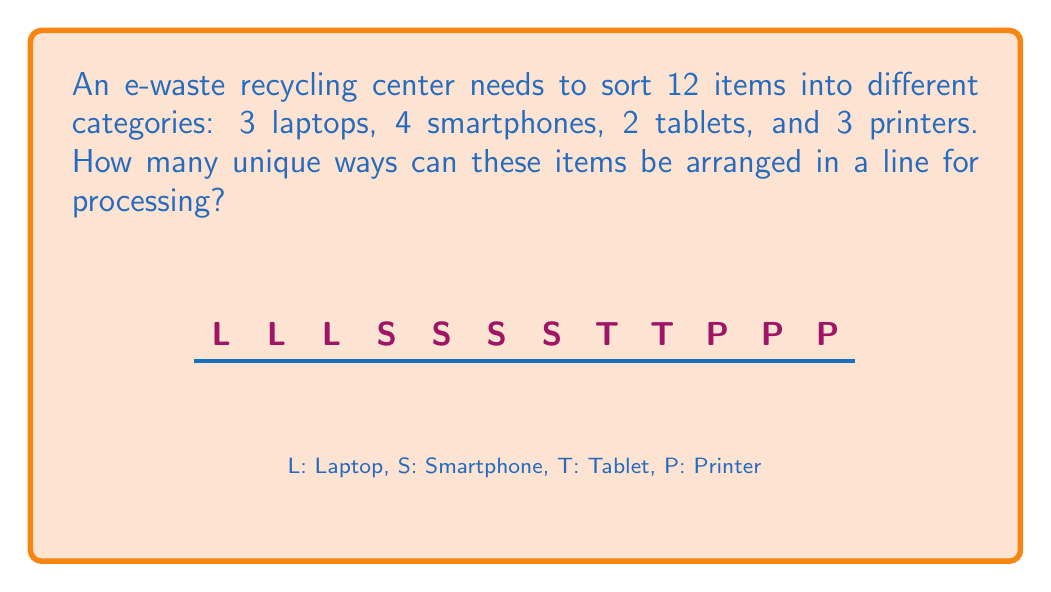What is the answer to this math problem? To solve this problem, we need to use the concept of permutations with repetition. The formula for this is:

$$\frac{n!}{n_1! \cdot n_2! \cdot ... \cdot n_k!}$$

Where:
- $n$ is the total number of items
- $n_1, n_2, ..., n_k$ are the numbers of each type of item

In this case:
- $n = 12$ (total items)
- $n_1 = 3$ (laptops)
- $n_2 = 4$ (smartphones)
- $n_3 = 2$ (tablets)
- $n_4 = 3$ (printers)

Plugging these values into the formula:

$$\frac{12!}{3! \cdot 4! \cdot 2! \cdot 3!}$$

Now, let's calculate:

1) $12! = 479,001,600$
2) $3! = 6$
3) $4! = 24$
4) $2! = 2$
5) $3! = 6$

Substituting these values:

$$\frac{479,001,600}{6 \cdot 24 \cdot 2 \cdot 6}$$

Simplifying:

$$\frac{479,001,600}{1,728} = 277,200$$

Therefore, there are 277,200 unique ways to arrange these e-waste items.
Answer: $277,200$ 